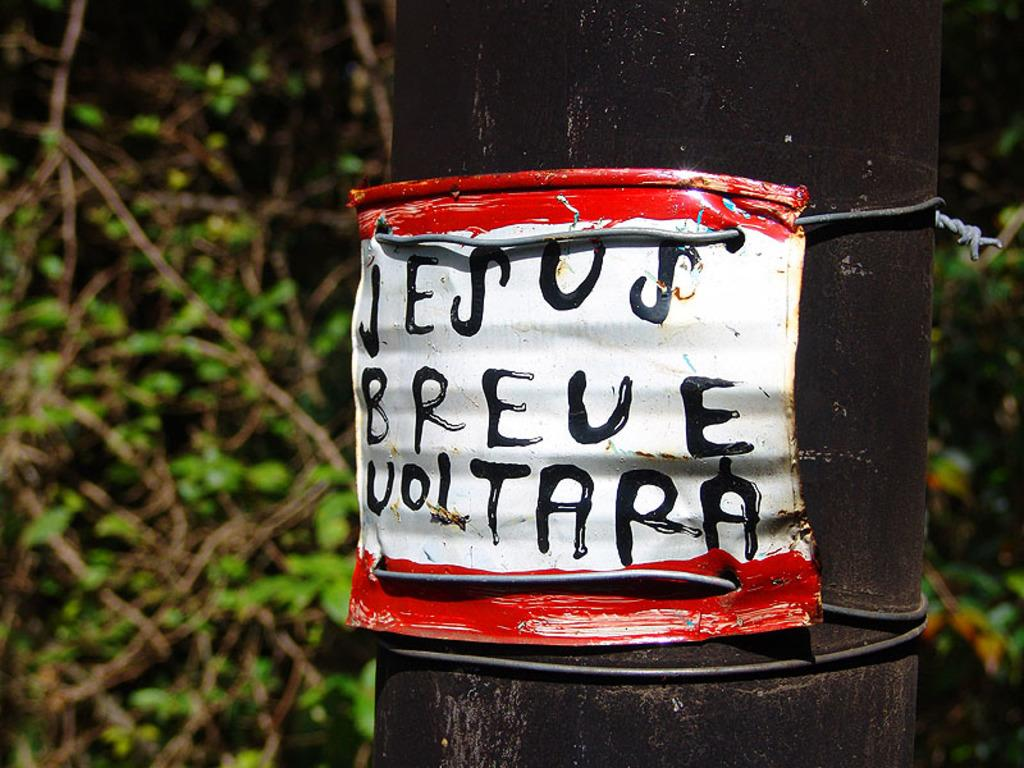What is written on in the image? There is text written on an object in the image. Where is the object with the text located? The object is attached to a pole on the right side of the image. What can be seen in the background of the image? There are trees visible in the background of the image. What type of jellyfish can be seen swimming in the image? There are no jellyfish present in the image; it features text on an object attached to a pole with trees in the background. 